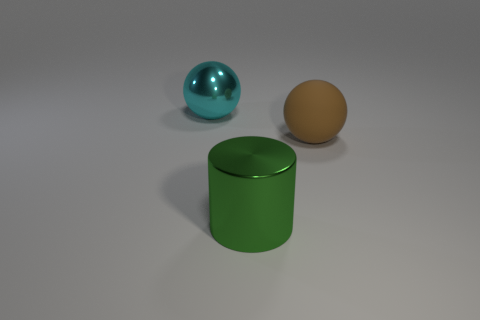Add 3 brown metal things. How many objects exist? 6 Subtract all balls. How many objects are left? 1 Subtract all cyan balls. Subtract all green cylinders. How many balls are left? 1 Subtract all brown spheres. Subtract all spheres. How many objects are left? 0 Add 1 rubber things. How many rubber things are left? 2 Add 2 large brown balls. How many large brown balls exist? 3 Subtract 1 green cylinders. How many objects are left? 2 